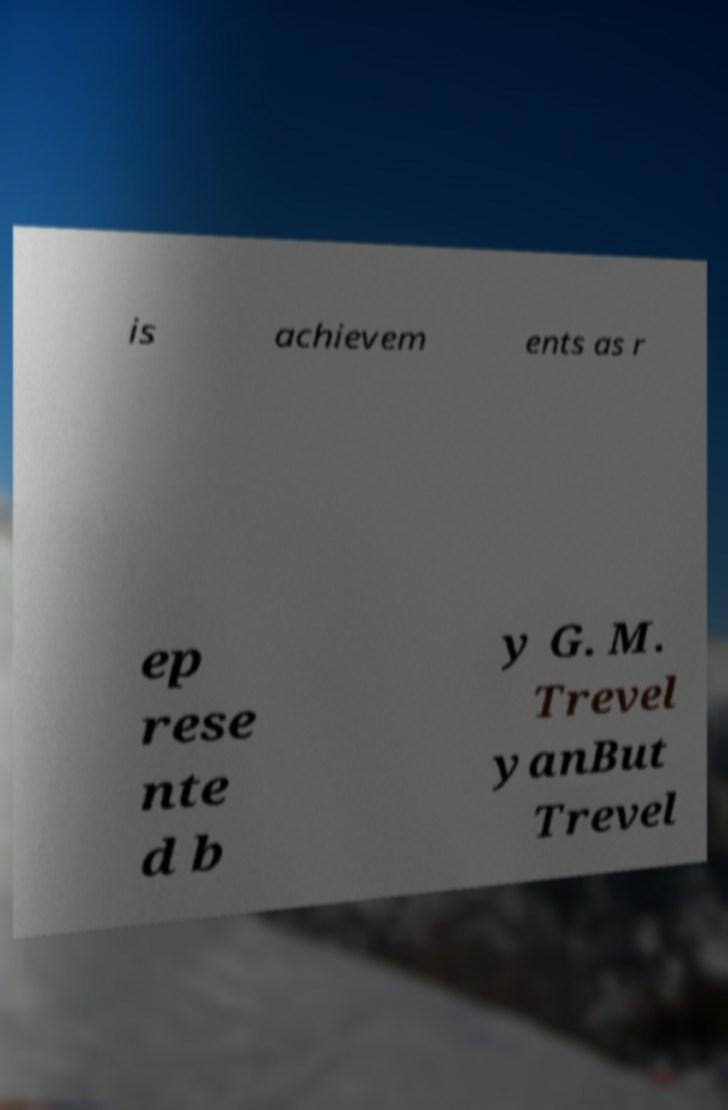Could you assist in decoding the text presented in this image and type it out clearly? is achievem ents as r ep rese nte d b y G. M. Trevel yanBut Trevel 